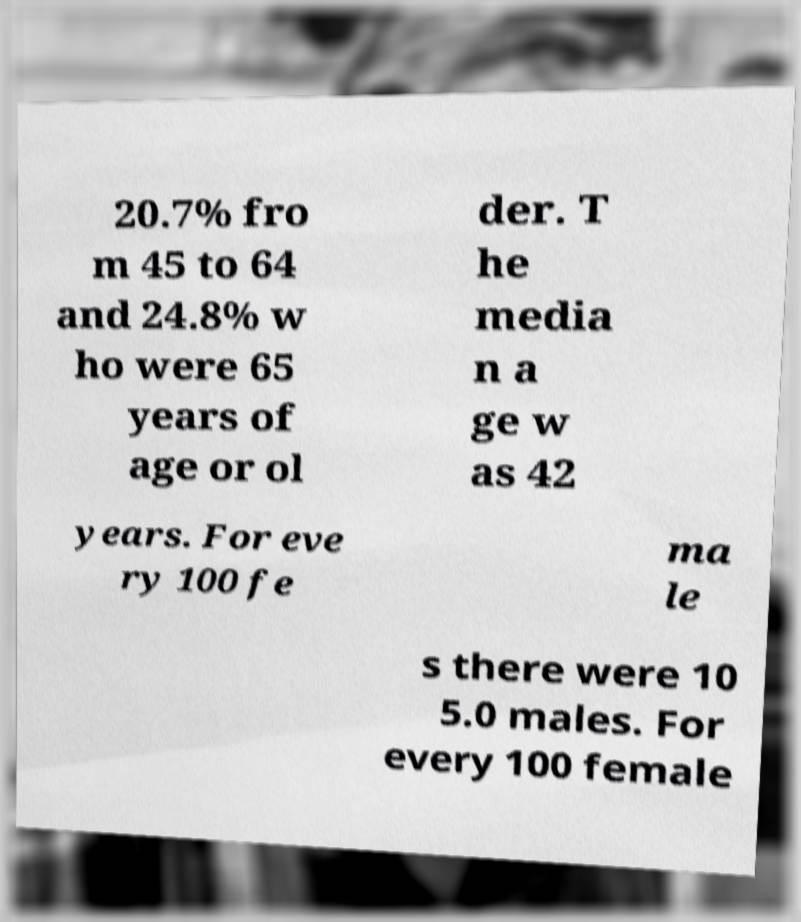Please identify and transcribe the text found in this image. 20.7% fro m 45 to 64 and 24.8% w ho were 65 years of age or ol der. T he media n a ge w as 42 years. For eve ry 100 fe ma le s there were 10 5.0 males. For every 100 female 